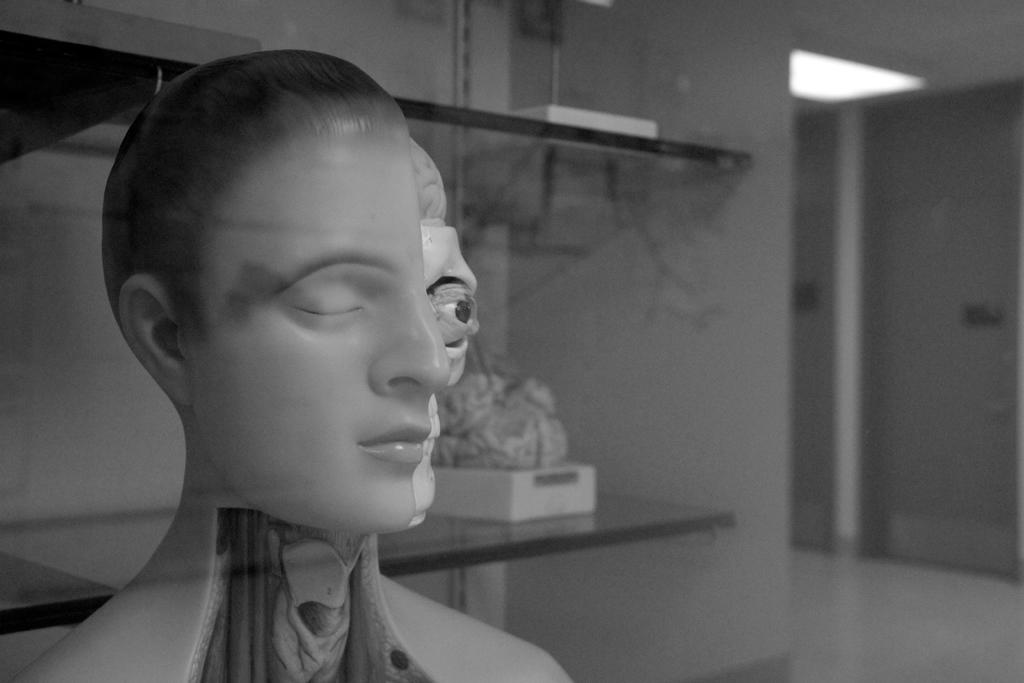What is the color scheme of the image? The image is black and white. What is the main subject in the image? There is a sculpture in the image. What can be seen in the background of the image? There are objects on a stand and a wall in the background of the image. What is the surface that the sculpture and other objects are placed on? There is a floor at the bottom of the image. What type of organization is depicted in the image? There is no organization depicted in the image; it features a sculpture and other objects in a black and white setting. What is the downtown area like in the image? There is no downtown area present in the image; it is a close-up view of a sculpture and other objects. 